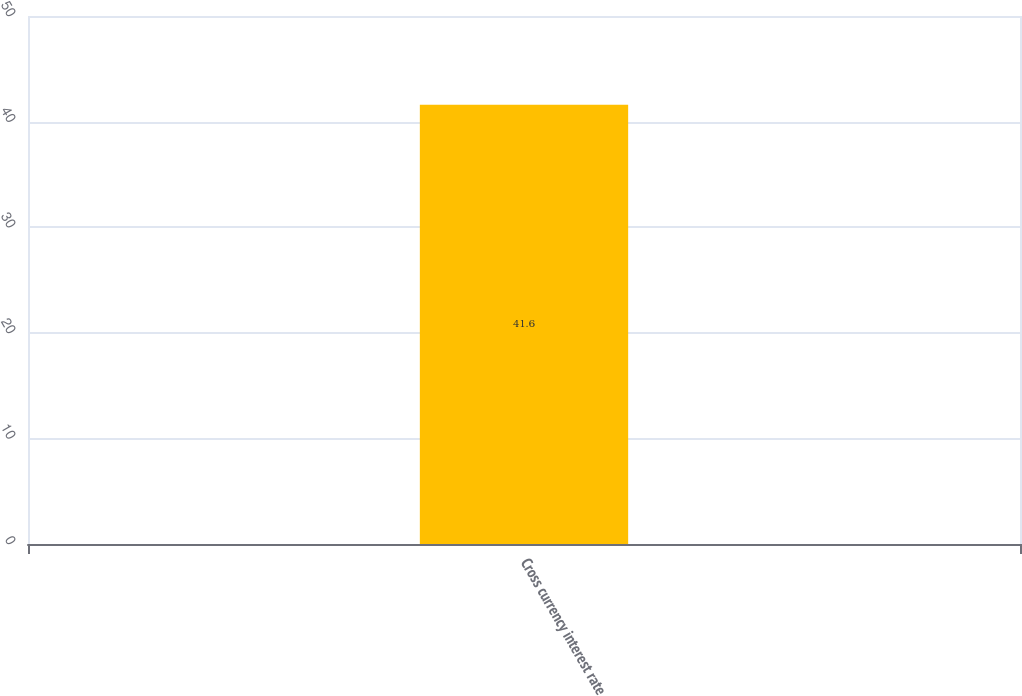<chart> <loc_0><loc_0><loc_500><loc_500><bar_chart><fcel>Cross currency interest rate<nl><fcel>41.6<nl></chart> 